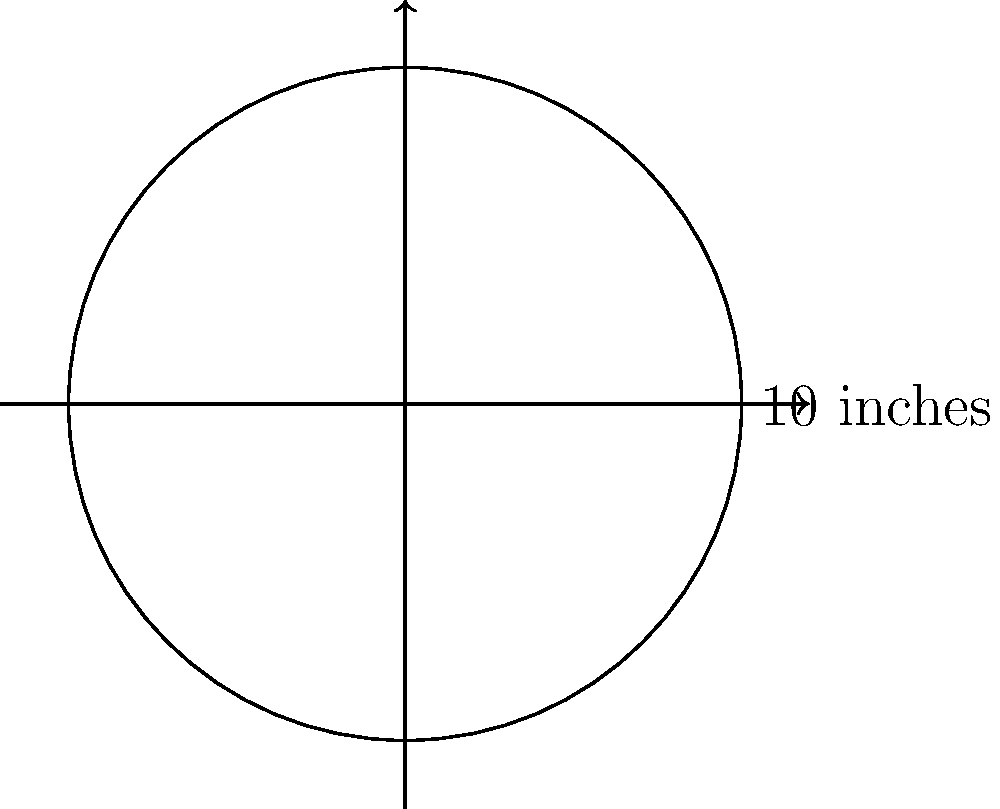You have a rare R.E.M. vinyl record with a diameter of 10 inches. What is the area of this record in square inches? Use $\pi \approx 3.14$ for your calculation. To find the area of a circular vinyl record, we need to follow these steps:

1. Recall the formula for the area of a circle: $A = \pi r^2$, where $r$ is the radius.

2. We're given the diameter, which is 10 inches. The radius is half of the diameter:
   $r = \frac{10}{2} = 5$ inches

3. Now we can substitute the values into the formula:
   $A = \pi r^2 = 3.14 \times 5^2$

4. Calculate $5^2$:
   $A = 3.14 \times 25$

5. Multiply:
   $A = 78.5$ square inches

Therefore, the area of the R.E.M. vinyl record is approximately 78.5 square inches.
Answer: $78.5$ square inches 